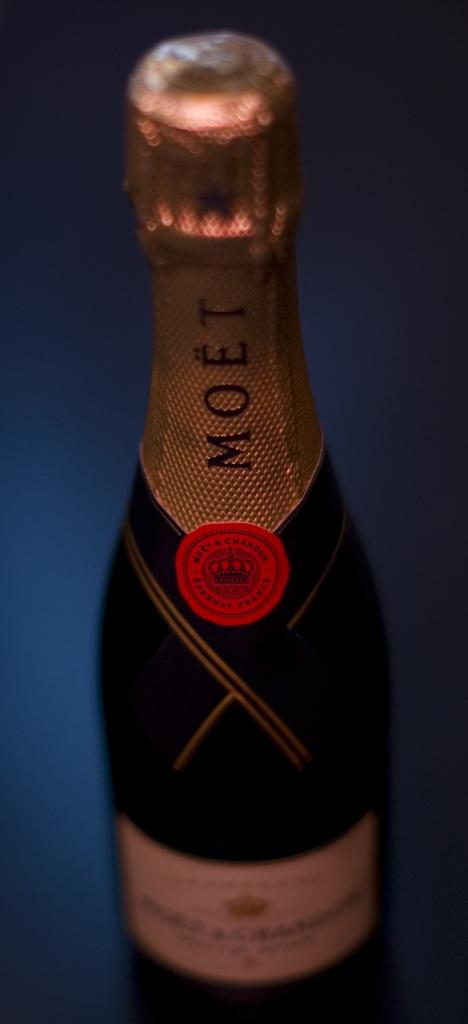Provide a one-sentence caption for the provided image. A bottle of Moet champagne sitting on a table. 